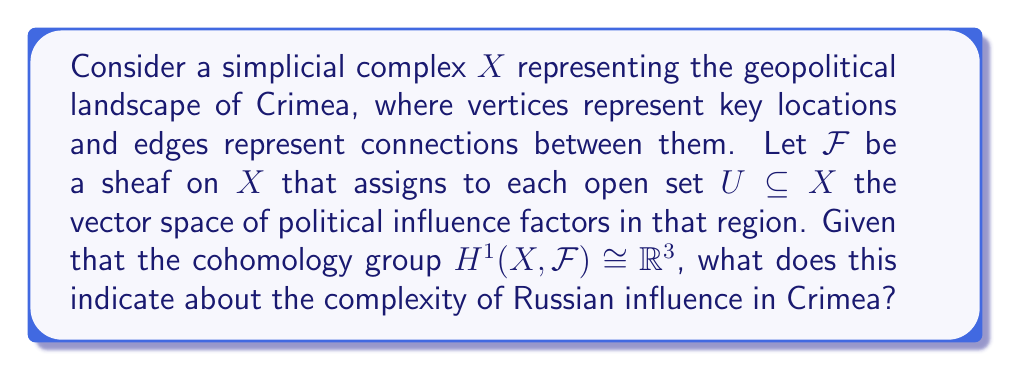Could you help me with this problem? To understand the significance of $H^1(X, \mathcal{F}) \cong \mathbb{R}^3$, let's break down the problem step-by-step:

1) The simplicial complex $X$ represents Crimea's geopolitical landscape. Vertices might represent cities, military bases, or strategic points, while edges represent connections or interactions between these locations.

2) The sheaf $\mathcal{F}$ assigns to each open set $U \subseteq X$ the vector space of political influence factors. This could include economic, cultural, and military influences.

3) In sheaf cohomology, $H^1(X, \mathcal{F})$ represents global obstructions to extending local sections of $\mathcal{F}$ to global sections.

4) The isomorphism $H^1(X, \mathcal{F}) \cong \mathbb{R}^3$ tells us that this cohomology group is 3-dimensional.

5) In the context of geopolitical influence:
   - $H^0(X, \mathcal{F})$ would represent globally consistent influence factors.
   - $H^1(X, \mathcal{F})$ represents the ways in which local influences fail to extend globally.

6) The fact that $H^1(X, \mathcal{F})$ is 3-dimensional suggests that there are three independent "obstacles" or "complexities" in the way Russian influence manifests across Crimea.

7) These three dimensions could correspond to different aspects of influence, such as:
   - Economic influence (e.g., trade dependencies)
   - Cultural influence (e.g., language and media)
   - Military influence (e.g., strategic positioning)

8) The non-zero dimension of $H^1(X, \mathcal{F})$ indicates that Russian influence is not uniform or straightforward across Crimea. There are local variations that don't extend globally in three independent ways.

Therefore, the 3-dimensional first cohomology group suggests a complex and multifaceted nature of Russian influence in Crimea, with three primary axes of variation or conflict.
Answer: The 3-dimensional $H^1(X, \mathcal{F})$ indicates three independent complexities in Russia's geopolitical influence over Crimea. 